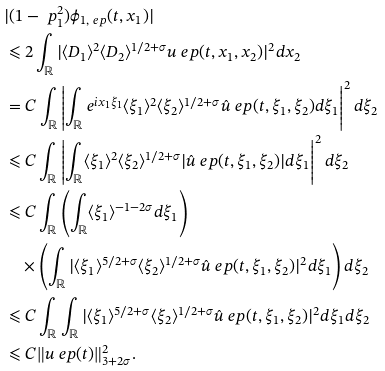<formula> <loc_0><loc_0><loc_500><loc_500>& | ( 1 - \ p _ { 1 } ^ { 2 } ) \phi _ { 1 , \ e p } ( t , x _ { 1 } ) | \\ & \leqslant 2 \int _ { \mathbb { R } } | \langle { D _ { 1 } } \rangle ^ { 2 } \langle { D _ { 2 } } \rangle ^ { 1 / 2 + \sigma } u _ { \ } e p ( t , x _ { 1 } , x _ { 2 } ) | ^ { 2 } d x _ { 2 } \\ & = C \int _ { \mathbb { R } } \left | \int _ { \mathbb { R } } e ^ { i x _ { 1 } \xi _ { 1 } } \langle \xi _ { 1 } \rangle ^ { 2 } \langle \xi _ { 2 } \rangle ^ { 1 / 2 + \sigma } \hat { u } _ { \ } e p ( t , \xi _ { 1 } , \xi _ { 2 } ) d \xi _ { 1 } \right | ^ { 2 } d \xi _ { 2 } \\ & \leqslant C \int _ { \mathbb { R } } \left | \int _ { \mathbb { R } } \langle \xi _ { 1 } \rangle ^ { 2 } \langle \xi _ { 2 } \rangle ^ { 1 / 2 + \sigma } | \hat { u } _ { \ } e p ( t , \xi _ { 1 } , \xi _ { 2 } ) | d \xi _ { 1 } \right | ^ { 2 } d \xi _ { 2 } \\ & \leqslant C \int _ { \mathbb { R } } \left ( \int _ { \mathbb { R } } \langle \xi _ { 1 } \rangle ^ { - 1 - 2 \sigma } d \xi _ { 1 } \right ) \\ & \quad \times \left ( \int _ { \mathbb { R } } | \langle \xi _ { 1 } \rangle ^ { 5 / 2 + \sigma } \langle \xi _ { 2 } \rangle ^ { 1 / 2 + \sigma } \hat { u } _ { \ } e p ( t , \xi _ { 1 } , \xi _ { 2 } ) | ^ { 2 } d \xi _ { 1 } \right ) d \xi _ { 2 } \\ & \leqslant C \int _ { \mathbb { R } } \int _ { \mathbb { R } } | \langle \xi _ { 1 } \rangle ^ { 5 / 2 + \sigma } \langle \xi _ { 2 } \rangle ^ { 1 / 2 + \sigma } \hat { u } _ { \ } e p ( t , \xi _ { 1 } , \xi _ { 2 } ) | ^ { 2 } d \xi _ { 1 } d \xi _ { 2 } \\ & \leqslant C \| { u _ { \ } e p } ( t ) \| _ { 3 + 2 \sigma } ^ { 2 } .</formula> 